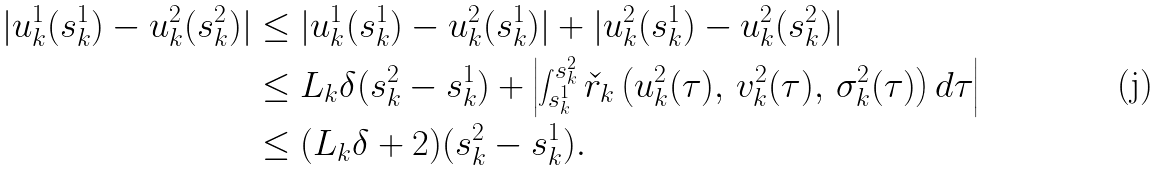Convert formula to latex. <formula><loc_0><loc_0><loc_500><loc_500>| u ^ { 1 } _ { k } ( s _ { k } ^ { 1 } ) - u ^ { 2 } _ { k } ( s _ { k } ^ { 2 } ) | & \leq | u ^ { 1 } _ { k } ( s _ { k } ^ { 1 } ) - u ^ { 2 } _ { k } ( s _ { k } ^ { 1 } ) | + | u ^ { 2 } _ { k } ( s _ { k } ^ { 1 } ) - u ^ { 2 } _ { k } ( s _ { k } ^ { 2 } ) | \\ & \leq L _ { k } \delta ( s ^ { 2 } _ { k } - s ^ { 1 } _ { k } ) + \left | \int _ { s ^ { 1 } _ { k } } ^ { s ^ { 2 } _ { k } } \check { r } _ { k } \left ( u ^ { 2 } _ { k } ( \tau ) , \, v ^ { 2 } _ { k } ( \tau ) , \, \sigma ^ { 2 } _ { k } ( \tau ) \right ) d \tau \right | \\ & \leq ( L _ { k } \delta + 2 ) ( s ^ { 2 } _ { k } - s ^ { 1 } _ { k } ) .</formula> 